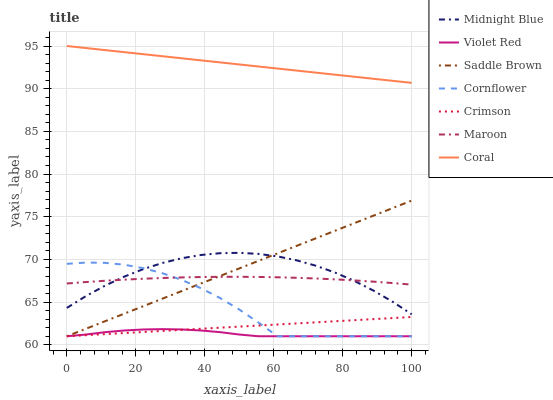Does Midnight Blue have the minimum area under the curve?
Answer yes or no. No. Does Midnight Blue have the maximum area under the curve?
Answer yes or no. No. Is Violet Red the smoothest?
Answer yes or no. No. Is Violet Red the roughest?
Answer yes or no. No. Does Midnight Blue have the lowest value?
Answer yes or no. No. Does Midnight Blue have the highest value?
Answer yes or no. No. Is Violet Red less than Maroon?
Answer yes or no. Yes. Is Coral greater than Violet Red?
Answer yes or no. Yes. Does Violet Red intersect Maroon?
Answer yes or no. No. 